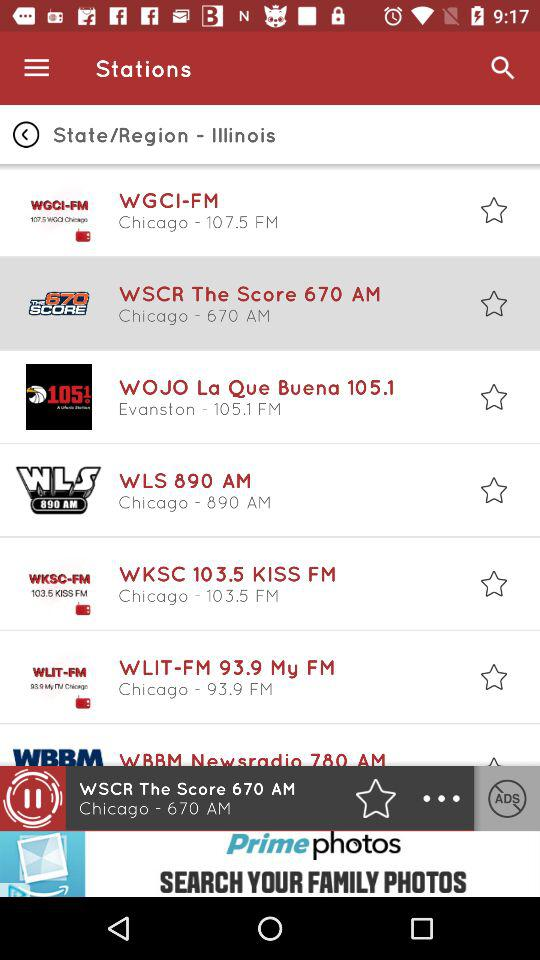What is the frequency of "WLS 890 AM"? The frequency of "WLS 890 AM" is 890 AM. 